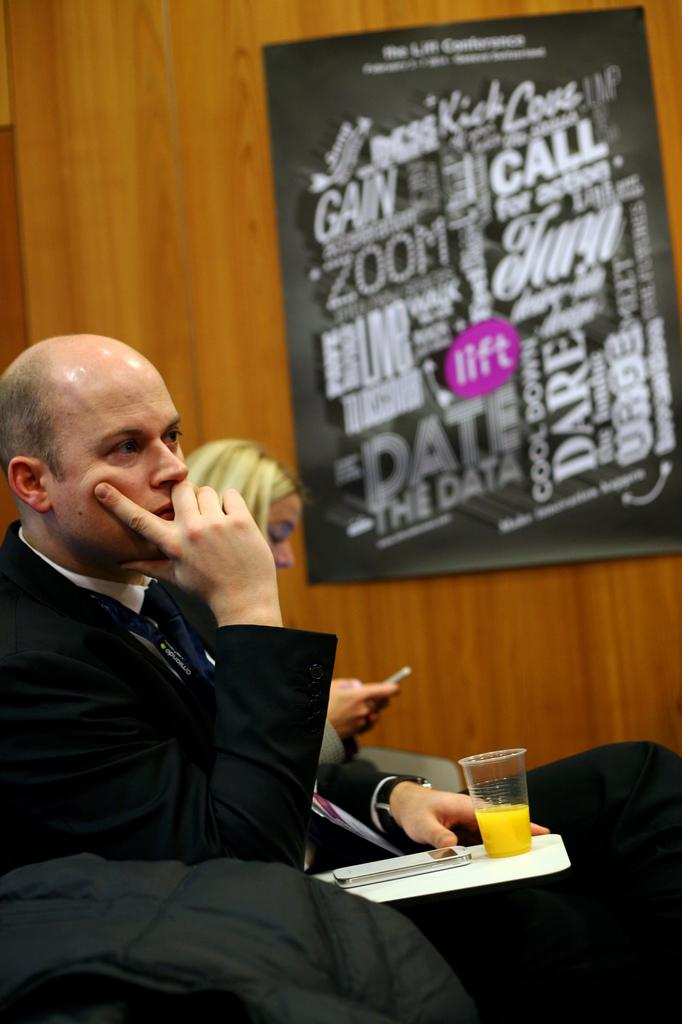<image>
Render a clear and concise summary of the photo. A man sitting with an orange juice with an unknown poster in the background describing Date, The Data ect. 